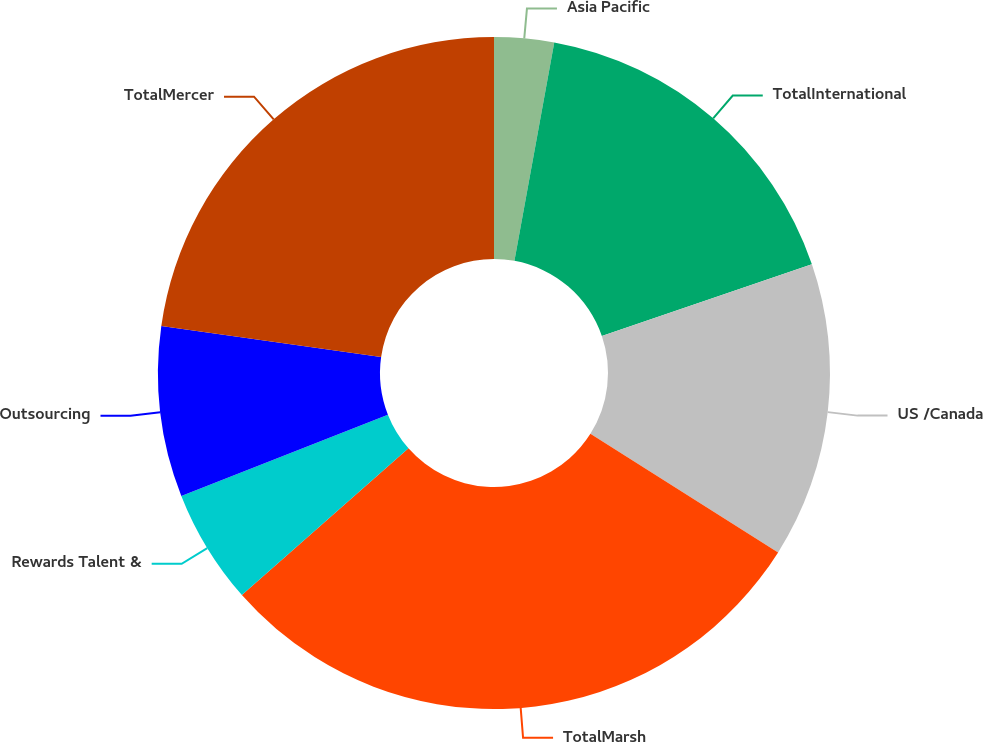Convert chart. <chart><loc_0><loc_0><loc_500><loc_500><pie_chart><fcel>Asia Pacific<fcel>TotalInternational<fcel>US /Canada<fcel>TotalMarsh<fcel>Rewards Talent &<fcel>Outsourcing<fcel>TotalMercer<nl><fcel>2.87%<fcel>16.88%<fcel>14.21%<fcel>29.54%<fcel>5.53%<fcel>8.2%<fcel>22.76%<nl></chart> 